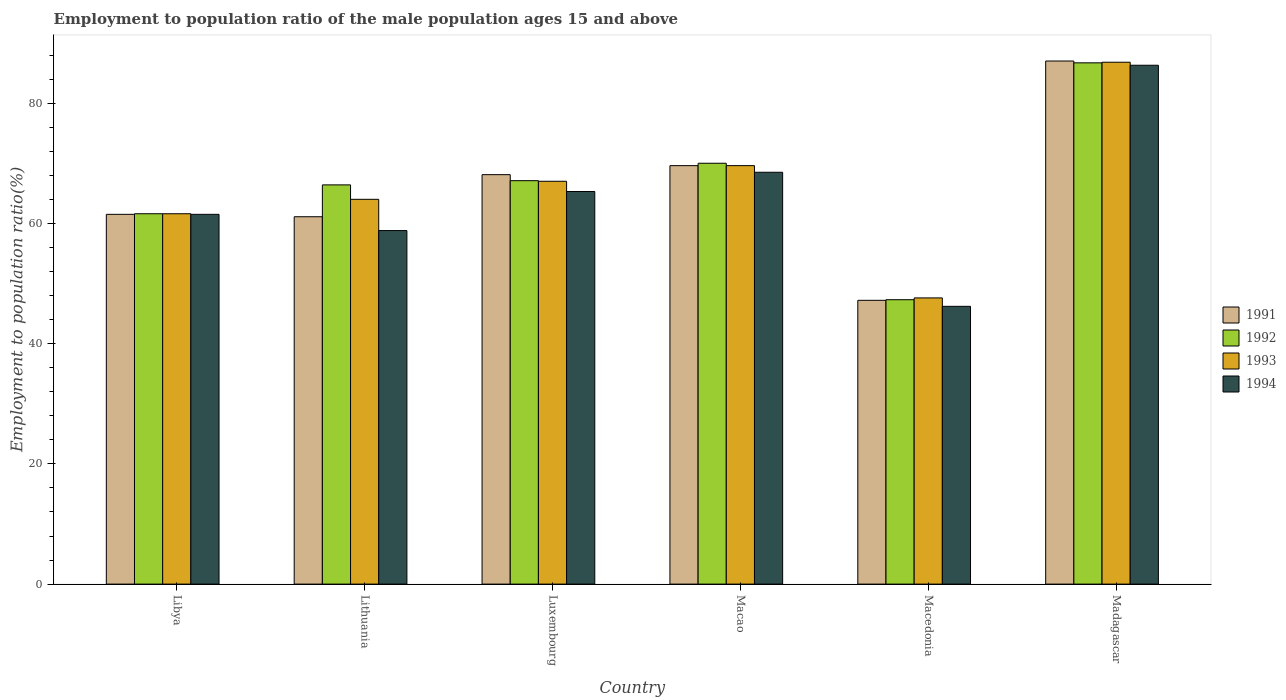Are the number of bars on each tick of the X-axis equal?
Provide a short and direct response. Yes. What is the label of the 4th group of bars from the left?
Offer a terse response. Macao. In how many cases, is the number of bars for a given country not equal to the number of legend labels?
Make the answer very short. 0. What is the employment to population ratio in 1993 in Macao?
Provide a succinct answer. 69.6. Across all countries, what is the maximum employment to population ratio in 1993?
Give a very brief answer. 86.8. Across all countries, what is the minimum employment to population ratio in 1991?
Make the answer very short. 47.2. In which country was the employment to population ratio in 1991 maximum?
Your answer should be compact. Madagascar. In which country was the employment to population ratio in 1991 minimum?
Ensure brevity in your answer.  Macedonia. What is the total employment to population ratio in 1993 in the graph?
Give a very brief answer. 396.6. What is the difference between the employment to population ratio in 1992 in Luxembourg and that in Macedonia?
Your answer should be very brief. 19.8. What is the difference between the employment to population ratio in 1992 in Macedonia and the employment to population ratio in 1993 in Luxembourg?
Keep it short and to the point. -19.7. What is the average employment to population ratio in 1993 per country?
Make the answer very short. 66.1. What is the difference between the employment to population ratio of/in 1992 and employment to population ratio of/in 1993 in Macao?
Make the answer very short. 0.4. What is the ratio of the employment to population ratio in 1993 in Luxembourg to that in Macao?
Your response must be concise. 0.96. Is the employment to population ratio in 1991 in Lithuania less than that in Madagascar?
Provide a succinct answer. Yes. Is the difference between the employment to population ratio in 1992 in Macao and Madagascar greater than the difference between the employment to population ratio in 1993 in Macao and Madagascar?
Give a very brief answer. Yes. What is the difference between the highest and the second highest employment to population ratio in 1992?
Offer a terse response. 2.9. What is the difference between the highest and the lowest employment to population ratio in 1992?
Make the answer very short. 39.4. Is the sum of the employment to population ratio in 1994 in Libya and Luxembourg greater than the maximum employment to population ratio in 1991 across all countries?
Make the answer very short. Yes. What does the 3rd bar from the right in Libya represents?
Give a very brief answer. 1992. Is it the case that in every country, the sum of the employment to population ratio in 1993 and employment to population ratio in 1994 is greater than the employment to population ratio in 1991?
Offer a terse response. Yes. How many bars are there?
Your answer should be compact. 24. Are all the bars in the graph horizontal?
Give a very brief answer. No. How many countries are there in the graph?
Provide a succinct answer. 6. What is the difference between two consecutive major ticks on the Y-axis?
Your response must be concise. 20. Are the values on the major ticks of Y-axis written in scientific E-notation?
Provide a succinct answer. No. How many legend labels are there?
Your answer should be very brief. 4. How are the legend labels stacked?
Provide a short and direct response. Vertical. What is the title of the graph?
Provide a succinct answer. Employment to population ratio of the male population ages 15 and above. Does "1977" appear as one of the legend labels in the graph?
Your answer should be compact. No. What is the label or title of the X-axis?
Ensure brevity in your answer.  Country. What is the Employment to population ratio(%) in 1991 in Libya?
Give a very brief answer. 61.5. What is the Employment to population ratio(%) in 1992 in Libya?
Your response must be concise. 61.6. What is the Employment to population ratio(%) of 1993 in Libya?
Make the answer very short. 61.6. What is the Employment to population ratio(%) in 1994 in Libya?
Offer a very short reply. 61.5. What is the Employment to population ratio(%) in 1991 in Lithuania?
Ensure brevity in your answer.  61.1. What is the Employment to population ratio(%) in 1992 in Lithuania?
Provide a succinct answer. 66.4. What is the Employment to population ratio(%) in 1993 in Lithuania?
Offer a very short reply. 64. What is the Employment to population ratio(%) in 1994 in Lithuania?
Offer a very short reply. 58.8. What is the Employment to population ratio(%) in 1991 in Luxembourg?
Offer a very short reply. 68.1. What is the Employment to population ratio(%) in 1992 in Luxembourg?
Give a very brief answer. 67.1. What is the Employment to population ratio(%) in 1993 in Luxembourg?
Give a very brief answer. 67. What is the Employment to population ratio(%) in 1994 in Luxembourg?
Ensure brevity in your answer.  65.3. What is the Employment to population ratio(%) in 1991 in Macao?
Ensure brevity in your answer.  69.6. What is the Employment to population ratio(%) of 1993 in Macao?
Give a very brief answer. 69.6. What is the Employment to population ratio(%) in 1994 in Macao?
Your answer should be very brief. 68.5. What is the Employment to population ratio(%) of 1991 in Macedonia?
Your answer should be very brief. 47.2. What is the Employment to population ratio(%) of 1992 in Macedonia?
Your response must be concise. 47.3. What is the Employment to population ratio(%) in 1993 in Macedonia?
Your response must be concise. 47.6. What is the Employment to population ratio(%) of 1994 in Macedonia?
Keep it short and to the point. 46.2. What is the Employment to population ratio(%) in 1991 in Madagascar?
Keep it short and to the point. 87. What is the Employment to population ratio(%) of 1992 in Madagascar?
Ensure brevity in your answer.  86.7. What is the Employment to population ratio(%) of 1993 in Madagascar?
Keep it short and to the point. 86.8. What is the Employment to population ratio(%) in 1994 in Madagascar?
Your answer should be compact. 86.3. Across all countries, what is the maximum Employment to population ratio(%) of 1991?
Provide a short and direct response. 87. Across all countries, what is the maximum Employment to population ratio(%) of 1992?
Offer a terse response. 86.7. Across all countries, what is the maximum Employment to population ratio(%) of 1993?
Give a very brief answer. 86.8. Across all countries, what is the maximum Employment to population ratio(%) in 1994?
Provide a succinct answer. 86.3. Across all countries, what is the minimum Employment to population ratio(%) of 1991?
Give a very brief answer. 47.2. Across all countries, what is the minimum Employment to population ratio(%) in 1992?
Offer a very short reply. 47.3. Across all countries, what is the minimum Employment to population ratio(%) in 1993?
Offer a terse response. 47.6. Across all countries, what is the minimum Employment to population ratio(%) of 1994?
Your response must be concise. 46.2. What is the total Employment to population ratio(%) of 1991 in the graph?
Keep it short and to the point. 394.5. What is the total Employment to population ratio(%) of 1992 in the graph?
Provide a succinct answer. 399.1. What is the total Employment to population ratio(%) of 1993 in the graph?
Your answer should be very brief. 396.6. What is the total Employment to population ratio(%) in 1994 in the graph?
Give a very brief answer. 386.6. What is the difference between the Employment to population ratio(%) of 1992 in Libya and that in Lithuania?
Keep it short and to the point. -4.8. What is the difference between the Employment to population ratio(%) of 1993 in Libya and that in Luxembourg?
Your answer should be very brief. -5.4. What is the difference between the Employment to population ratio(%) of 1994 in Libya and that in Luxembourg?
Keep it short and to the point. -3.8. What is the difference between the Employment to population ratio(%) of 1991 in Libya and that in Macao?
Ensure brevity in your answer.  -8.1. What is the difference between the Employment to population ratio(%) in 1992 in Libya and that in Macao?
Your answer should be very brief. -8.4. What is the difference between the Employment to population ratio(%) in 1993 in Libya and that in Macao?
Provide a short and direct response. -8. What is the difference between the Employment to population ratio(%) of 1991 in Libya and that in Macedonia?
Offer a terse response. 14.3. What is the difference between the Employment to population ratio(%) of 1994 in Libya and that in Macedonia?
Provide a short and direct response. 15.3. What is the difference between the Employment to population ratio(%) in 1991 in Libya and that in Madagascar?
Give a very brief answer. -25.5. What is the difference between the Employment to population ratio(%) in 1992 in Libya and that in Madagascar?
Your answer should be compact. -25.1. What is the difference between the Employment to population ratio(%) in 1993 in Libya and that in Madagascar?
Keep it short and to the point. -25.2. What is the difference between the Employment to population ratio(%) in 1994 in Libya and that in Madagascar?
Give a very brief answer. -24.8. What is the difference between the Employment to population ratio(%) in 1991 in Lithuania and that in Luxembourg?
Provide a succinct answer. -7. What is the difference between the Employment to population ratio(%) in 1992 in Lithuania and that in Luxembourg?
Ensure brevity in your answer.  -0.7. What is the difference between the Employment to population ratio(%) of 1993 in Lithuania and that in Luxembourg?
Give a very brief answer. -3. What is the difference between the Employment to population ratio(%) in 1994 in Lithuania and that in Luxembourg?
Offer a very short reply. -6.5. What is the difference between the Employment to population ratio(%) of 1991 in Lithuania and that in Macao?
Provide a succinct answer. -8.5. What is the difference between the Employment to population ratio(%) of 1993 in Lithuania and that in Macao?
Give a very brief answer. -5.6. What is the difference between the Employment to population ratio(%) of 1993 in Lithuania and that in Macedonia?
Offer a very short reply. 16.4. What is the difference between the Employment to population ratio(%) in 1991 in Lithuania and that in Madagascar?
Provide a succinct answer. -25.9. What is the difference between the Employment to population ratio(%) of 1992 in Lithuania and that in Madagascar?
Your answer should be very brief. -20.3. What is the difference between the Employment to population ratio(%) of 1993 in Lithuania and that in Madagascar?
Offer a terse response. -22.8. What is the difference between the Employment to population ratio(%) of 1994 in Lithuania and that in Madagascar?
Provide a short and direct response. -27.5. What is the difference between the Employment to population ratio(%) of 1991 in Luxembourg and that in Macao?
Offer a terse response. -1.5. What is the difference between the Employment to population ratio(%) of 1993 in Luxembourg and that in Macao?
Provide a short and direct response. -2.6. What is the difference between the Employment to population ratio(%) in 1991 in Luxembourg and that in Macedonia?
Your response must be concise. 20.9. What is the difference between the Employment to population ratio(%) in 1992 in Luxembourg and that in Macedonia?
Your response must be concise. 19.8. What is the difference between the Employment to population ratio(%) in 1993 in Luxembourg and that in Macedonia?
Provide a short and direct response. 19.4. What is the difference between the Employment to population ratio(%) of 1994 in Luxembourg and that in Macedonia?
Offer a very short reply. 19.1. What is the difference between the Employment to population ratio(%) of 1991 in Luxembourg and that in Madagascar?
Make the answer very short. -18.9. What is the difference between the Employment to population ratio(%) of 1992 in Luxembourg and that in Madagascar?
Your response must be concise. -19.6. What is the difference between the Employment to population ratio(%) in 1993 in Luxembourg and that in Madagascar?
Make the answer very short. -19.8. What is the difference between the Employment to population ratio(%) of 1994 in Luxembourg and that in Madagascar?
Give a very brief answer. -21. What is the difference between the Employment to population ratio(%) in 1991 in Macao and that in Macedonia?
Provide a succinct answer. 22.4. What is the difference between the Employment to population ratio(%) of 1992 in Macao and that in Macedonia?
Keep it short and to the point. 22.7. What is the difference between the Employment to population ratio(%) of 1993 in Macao and that in Macedonia?
Your response must be concise. 22. What is the difference between the Employment to population ratio(%) in 1994 in Macao and that in Macedonia?
Your response must be concise. 22.3. What is the difference between the Employment to population ratio(%) of 1991 in Macao and that in Madagascar?
Offer a very short reply. -17.4. What is the difference between the Employment to population ratio(%) in 1992 in Macao and that in Madagascar?
Provide a succinct answer. -16.7. What is the difference between the Employment to population ratio(%) in 1993 in Macao and that in Madagascar?
Provide a short and direct response. -17.2. What is the difference between the Employment to population ratio(%) of 1994 in Macao and that in Madagascar?
Offer a very short reply. -17.8. What is the difference between the Employment to population ratio(%) of 1991 in Macedonia and that in Madagascar?
Offer a terse response. -39.8. What is the difference between the Employment to population ratio(%) in 1992 in Macedonia and that in Madagascar?
Your answer should be very brief. -39.4. What is the difference between the Employment to population ratio(%) in 1993 in Macedonia and that in Madagascar?
Your response must be concise. -39.2. What is the difference between the Employment to population ratio(%) in 1994 in Macedonia and that in Madagascar?
Your answer should be very brief. -40.1. What is the difference between the Employment to population ratio(%) in 1991 in Libya and the Employment to population ratio(%) in 1992 in Lithuania?
Offer a very short reply. -4.9. What is the difference between the Employment to population ratio(%) of 1991 in Libya and the Employment to population ratio(%) of 1993 in Lithuania?
Give a very brief answer. -2.5. What is the difference between the Employment to population ratio(%) of 1991 in Libya and the Employment to population ratio(%) of 1994 in Lithuania?
Offer a terse response. 2.7. What is the difference between the Employment to population ratio(%) of 1992 in Libya and the Employment to population ratio(%) of 1993 in Lithuania?
Your answer should be compact. -2.4. What is the difference between the Employment to population ratio(%) in 1993 in Libya and the Employment to population ratio(%) in 1994 in Lithuania?
Offer a terse response. 2.8. What is the difference between the Employment to population ratio(%) in 1991 in Libya and the Employment to population ratio(%) in 1992 in Luxembourg?
Your answer should be compact. -5.6. What is the difference between the Employment to population ratio(%) of 1992 in Libya and the Employment to population ratio(%) of 1994 in Luxembourg?
Your answer should be very brief. -3.7. What is the difference between the Employment to population ratio(%) in 1993 in Libya and the Employment to population ratio(%) in 1994 in Luxembourg?
Ensure brevity in your answer.  -3.7. What is the difference between the Employment to population ratio(%) of 1991 in Libya and the Employment to population ratio(%) of 1993 in Macao?
Offer a terse response. -8.1. What is the difference between the Employment to population ratio(%) of 1992 in Libya and the Employment to population ratio(%) of 1994 in Macao?
Offer a very short reply. -6.9. What is the difference between the Employment to population ratio(%) of 1993 in Libya and the Employment to population ratio(%) of 1994 in Macao?
Provide a succinct answer. -6.9. What is the difference between the Employment to population ratio(%) in 1992 in Libya and the Employment to population ratio(%) in 1993 in Macedonia?
Ensure brevity in your answer.  14. What is the difference between the Employment to population ratio(%) in 1991 in Libya and the Employment to population ratio(%) in 1992 in Madagascar?
Provide a succinct answer. -25.2. What is the difference between the Employment to population ratio(%) of 1991 in Libya and the Employment to population ratio(%) of 1993 in Madagascar?
Provide a succinct answer. -25.3. What is the difference between the Employment to population ratio(%) in 1991 in Libya and the Employment to population ratio(%) in 1994 in Madagascar?
Offer a terse response. -24.8. What is the difference between the Employment to population ratio(%) of 1992 in Libya and the Employment to population ratio(%) of 1993 in Madagascar?
Ensure brevity in your answer.  -25.2. What is the difference between the Employment to population ratio(%) of 1992 in Libya and the Employment to population ratio(%) of 1994 in Madagascar?
Provide a short and direct response. -24.7. What is the difference between the Employment to population ratio(%) of 1993 in Libya and the Employment to population ratio(%) of 1994 in Madagascar?
Provide a succinct answer. -24.7. What is the difference between the Employment to population ratio(%) in 1991 in Lithuania and the Employment to population ratio(%) in 1992 in Luxembourg?
Your answer should be very brief. -6. What is the difference between the Employment to population ratio(%) in 1992 in Lithuania and the Employment to population ratio(%) in 1994 in Luxembourg?
Provide a short and direct response. 1.1. What is the difference between the Employment to population ratio(%) of 1991 in Lithuania and the Employment to population ratio(%) of 1993 in Macao?
Make the answer very short. -8.5. What is the difference between the Employment to population ratio(%) of 1991 in Lithuania and the Employment to population ratio(%) of 1994 in Macao?
Your response must be concise. -7.4. What is the difference between the Employment to population ratio(%) in 1992 in Lithuania and the Employment to population ratio(%) in 1993 in Macao?
Provide a succinct answer. -3.2. What is the difference between the Employment to population ratio(%) of 1991 in Lithuania and the Employment to population ratio(%) of 1992 in Macedonia?
Offer a very short reply. 13.8. What is the difference between the Employment to population ratio(%) of 1991 in Lithuania and the Employment to population ratio(%) of 1993 in Macedonia?
Ensure brevity in your answer.  13.5. What is the difference between the Employment to population ratio(%) of 1991 in Lithuania and the Employment to population ratio(%) of 1994 in Macedonia?
Keep it short and to the point. 14.9. What is the difference between the Employment to population ratio(%) of 1992 in Lithuania and the Employment to population ratio(%) of 1994 in Macedonia?
Offer a terse response. 20.2. What is the difference between the Employment to population ratio(%) of 1993 in Lithuania and the Employment to population ratio(%) of 1994 in Macedonia?
Keep it short and to the point. 17.8. What is the difference between the Employment to population ratio(%) in 1991 in Lithuania and the Employment to population ratio(%) in 1992 in Madagascar?
Your answer should be very brief. -25.6. What is the difference between the Employment to population ratio(%) of 1991 in Lithuania and the Employment to population ratio(%) of 1993 in Madagascar?
Your answer should be compact. -25.7. What is the difference between the Employment to population ratio(%) of 1991 in Lithuania and the Employment to population ratio(%) of 1994 in Madagascar?
Offer a terse response. -25.2. What is the difference between the Employment to population ratio(%) of 1992 in Lithuania and the Employment to population ratio(%) of 1993 in Madagascar?
Give a very brief answer. -20.4. What is the difference between the Employment to population ratio(%) of 1992 in Lithuania and the Employment to population ratio(%) of 1994 in Madagascar?
Ensure brevity in your answer.  -19.9. What is the difference between the Employment to population ratio(%) in 1993 in Lithuania and the Employment to population ratio(%) in 1994 in Madagascar?
Your answer should be compact. -22.3. What is the difference between the Employment to population ratio(%) in 1991 in Luxembourg and the Employment to population ratio(%) in 1993 in Macao?
Provide a succinct answer. -1.5. What is the difference between the Employment to population ratio(%) of 1991 in Luxembourg and the Employment to population ratio(%) of 1994 in Macao?
Ensure brevity in your answer.  -0.4. What is the difference between the Employment to population ratio(%) of 1992 in Luxembourg and the Employment to population ratio(%) of 1993 in Macao?
Ensure brevity in your answer.  -2.5. What is the difference between the Employment to population ratio(%) in 1992 in Luxembourg and the Employment to population ratio(%) in 1994 in Macao?
Offer a very short reply. -1.4. What is the difference between the Employment to population ratio(%) in 1991 in Luxembourg and the Employment to population ratio(%) in 1992 in Macedonia?
Your answer should be compact. 20.8. What is the difference between the Employment to population ratio(%) in 1991 in Luxembourg and the Employment to population ratio(%) in 1993 in Macedonia?
Provide a succinct answer. 20.5. What is the difference between the Employment to population ratio(%) of 1991 in Luxembourg and the Employment to population ratio(%) of 1994 in Macedonia?
Offer a terse response. 21.9. What is the difference between the Employment to population ratio(%) of 1992 in Luxembourg and the Employment to population ratio(%) of 1993 in Macedonia?
Your response must be concise. 19.5. What is the difference between the Employment to population ratio(%) of 1992 in Luxembourg and the Employment to population ratio(%) of 1994 in Macedonia?
Ensure brevity in your answer.  20.9. What is the difference between the Employment to population ratio(%) in 1993 in Luxembourg and the Employment to population ratio(%) in 1994 in Macedonia?
Your answer should be compact. 20.8. What is the difference between the Employment to population ratio(%) in 1991 in Luxembourg and the Employment to population ratio(%) in 1992 in Madagascar?
Provide a short and direct response. -18.6. What is the difference between the Employment to population ratio(%) in 1991 in Luxembourg and the Employment to population ratio(%) in 1993 in Madagascar?
Offer a terse response. -18.7. What is the difference between the Employment to population ratio(%) in 1991 in Luxembourg and the Employment to population ratio(%) in 1994 in Madagascar?
Make the answer very short. -18.2. What is the difference between the Employment to population ratio(%) in 1992 in Luxembourg and the Employment to population ratio(%) in 1993 in Madagascar?
Your answer should be compact. -19.7. What is the difference between the Employment to population ratio(%) in 1992 in Luxembourg and the Employment to population ratio(%) in 1994 in Madagascar?
Ensure brevity in your answer.  -19.2. What is the difference between the Employment to population ratio(%) of 1993 in Luxembourg and the Employment to population ratio(%) of 1994 in Madagascar?
Offer a terse response. -19.3. What is the difference between the Employment to population ratio(%) of 1991 in Macao and the Employment to population ratio(%) of 1992 in Macedonia?
Keep it short and to the point. 22.3. What is the difference between the Employment to population ratio(%) of 1991 in Macao and the Employment to population ratio(%) of 1993 in Macedonia?
Give a very brief answer. 22. What is the difference between the Employment to population ratio(%) of 1991 in Macao and the Employment to population ratio(%) of 1994 in Macedonia?
Give a very brief answer. 23.4. What is the difference between the Employment to population ratio(%) of 1992 in Macao and the Employment to population ratio(%) of 1993 in Macedonia?
Provide a short and direct response. 22.4. What is the difference between the Employment to population ratio(%) of 1992 in Macao and the Employment to population ratio(%) of 1994 in Macedonia?
Provide a succinct answer. 23.8. What is the difference between the Employment to population ratio(%) in 1993 in Macao and the Employment to population ratio(%) in 1994 in Macedonia?
Offer a terse response. 23.4. What is the difference between the Employment to population ratio(%) of 1991 in Macao and the Employment to population ratio(%) of 1992 in Madagascar?
Make the answer very short. -17.1. What is the difference between the Employment to population ratio(%) of 1991 in Macao and the Employment to population ratio(%) of 1993 in Madagascar?
Your answer should be very brief. -17.2. What is the difference between the Employment to population ratio(%) of 1991 in Macao and the Employment to population ratio(%) of 1994 in Madagascar?
Offer a very short reply. -16.7. What is the difference between the Employment to population ratio(%) in 1992 in Macao and the Employment to population ratio(%) in 1993 in Madagascar?
Ensure brevity in your answer.  -16.8. What is the difference between the Employment to population ratio(%) of 1992 in Macao and the Employment to population ratio(%) of 1994 in Madagascar?
Your answer should be compact. -16.3. What is the difference between the Employment to population ratio(%) in 1993 in Macao and the Employment to population ratio(%) in 1994 in Madagascar?
Make the answer very short. -16.7. What is the difference between the Employment to population ratio(%) of 1991 in Macedonia and the Employment to population ratio(%) of 1992 in Madagascar?
Offer a terse response. -39.5. What is the difference between the Employment to population ratio(%) of 1991 in Macedonia and the Employment to population ratio(%) of 1993 in Madagascar?
Your response must be concise. -39.6. What is the difference between the Employment to population ratio(%) in 1991 in Macedonia and the Employment to population ratio(%) in 1994 in Madagascar?
Offer a very short reply. -39.1. What is the difference between the Employment to population ratio(%) in 1992 in Macedonia and the Employment to population ratio(%) in 1993 in Madagascar?
Your answer should be very brief. -39.5. What is the difference between the Employment to population ratio(%) of 1992 in Macedonia and the Employment to population ratio(%) of 1994 in Madagascar?
Keep it short and to the point. -39. What is the difference between the Employment to population ratio(%) of 1993 in Macedonia and the Employment to population ratio(%) of 1994 in Madagascar?
Your answer should be very brief. -38.7. What is the average Employment to population ratio(%) of 1991 per country?
Keep it short and to the point. 65.75. What is the average Employment to population ratio(%) in 1992 per country?
Provide a succinct answer. 66.52. What is the average Employment to population ratio(%) in 1993 per country?
Offer a very short reply. 66.1. What is the average Employment to population ratio(%) in 1994 per country?
Your answer should be very brief. 64.43. What is the difference between the Employment to population ratio(%) of 1991 and Employment to population ratio(%) of 1993 in Libya?
Make the answer very short. -0.1. What is the difference between the Employment to population ratio(%) in 1992 and Employment to population ratio(%) in 1993 in Libya?
Offer a very short reply. 0. What is the difference between the Employment to population ratio(%) of 1992 and Employment to population ratio(%) of 1994 in Libya?
Your answer should be compact. 0.1. What is the difference between the Employment to population ratio(%) of 1993 and Employment to population ratio(%) of 1994 in Libya?
Provide a short and direct response. 0.1. What is the difference between the Employment to population ratio(%) in 1991 and Employment to population ratio(%) in 1993 in Lithuania?
Keep it short and to the point. -2.9. What is the difference between the Employment to population ratio(%) in 1992 and Employment to population ratio(%) in 1993 in Lithuania?
Keep it short and to the point. 2.4. What is the difference between the Employment to population ratio(%) in 1991 and Employment to population ratio(%) in 1992 in Luxembourg?
Your answer should be compact. 1. What is the difference between the Employment to population ratio(%) of 1992 and Employment to population ratio(%) of 1994 in Luxembourg?
Your answer should be very brief. 1.8. What is the difference between the Employment to population ratio(%) of 1993 and Employment to population ratio(%) of 1994 in Luxembourg?
Offer a very short reply. 1.7. What is the difference between the Employment to population ratio(%) in 1991 and Employment to population ratio(%) in 1993 in Macao?
Provide a short and direct response. 0. What is the difference between the Employment to population ratio(%) in 1992 and Employment to population ratio(%) in 1993 in Macao?
Your response must be concise. 0.4. What is the difference between the Employment to population ratio(%) of 1992 and Employment to population ratio(%) of 1994 in Macao?
Your response must be concise. 1.5. What is the difference between the Employment to population ratio(%) in 1991 and Employment to population ratio(%) in 1993 in Macedonia?
Provide a succinct answer. -0.4. What is the difference between the Employment to population ratio(%) in 1991 and Employment to population ratio(%) in 1994 in Macedonia?
Provide a succinct answer. 1. What is the difference between the Employment to population ratio(%) in 1992 and Employment to population ratio(%) in 1993 in Macedonia?
Your response must be concise. -0.3. What is the difference between the Employment to population ratio(%) in 1991 and Employment to population ratio(%) in 1992 in Madagascar?
Your response must be concise. 0.3. What is the difference between the Employment to population ratio(%) in 1991 and Employment to population ratio(%) in 1994 in Madagascar?
Your answer should be very brief. 0.7. What is the ratio of the Employment to population ratio(%) in 1992 in Libya to that in Lithuania?
Your answer should be very brief. 0.93. What is the ratio of the Employment to population ratio(%) of 1993 in Libya to that in Lithuania?
Offer a terse response. 0.96. What is the ratio of the Employment to population ratio(%) in 1994 in Libya to that in Lithuania?
Make the answer very short. 1.05. What is the ratio of the Employment to population ratio(%) of 1991 in Libya to that in Luxembourg?
Offer a terse response. 0.9. What is the ratio of the Employment to population ratio(%) in 1992 in Libya to that in Luxembourg?
Your answer should be compact. 0.92. What is the ratio of the Employment to population ratio(%) in 1993 in Libya to that in Luxembourg?
Provide a succinct answer. 0.92. What is the ratio of the Employment to population ratio(%) in 1994 in Libya to that in Luxembourg?
Ensure brevity in your answer.  0.94. What is the ratio of the Employment to population ratio(%) of 1991 in Libya to that in Macao?
Offer a terse response. 0.88. What is the ratio of the Employment to population ratio(%) in 1993 in Libya to that in Macao?
Make the answer very short. 0.89. What is the ratio of the Employment to population ratio(%) of 1994 in Libya to that in Macao?
Your answer should be compact. 0.9. What is the ratio of the Employment to population ratio(%) of 1991 in Libya to that in Macedonia?
Your response must be concise. 1.3. What is the ratio of the Employment to population ratio(%) in 1992 in Libya to that in Macedonia?
Provide a short and direct response. 1.3. What is the ratio of the Employment to population ratio(%) of 1993 in Libya to that in Macedonia?
Offer a terse response. 1.29. What is the ratio of the Employment to population ratio(%) of 1994 in Libya to that in Macedonia?
Keep it short and to the point. 1.33. What is the ratio of the Employment to population ratio(%) in 1991 in Libya to that in Madagascar?
Your response must be concise. 0.71. What is the ratio of the Employment to population ratio(%) in 1992 in Libya to that in Madagascar?
Offer a very short reply. 0.71. What is the ratio of the Employment to population ratio(%) in 1993 in Libya to that in Madagascar?
Offer a very short reply. 0.71. What is the ratio of the Employment to population ratio(%) of 1994 in Libya to that in Madagascar?
Keep it short and to the point. 0.71. What is the ratio of the Employment to population ratio(%) of 1991 in Lithuania to that in Luxembourg?
Offer a terse response. 0.9. What is the ratio of the Employment to population ratio(%) in 1992 in Lithuania to that in Luxembourg?
Keep it short and to the point. 0.99. What is the ratio of the Employment to population ratio(%) of 1993 in Lithuania to that in Luxembourg?
Offer a terse response. 0.96. What is the ratio of the Employment to population ratio(%) in 1994 in Lithuania to that in Luxembourg?
Provide a short and direct response. 0.9. What is the ratio of the Employment to population ratio(%) of 1991 in Lithuania to that in Macao?
Give a very brief answer. 0.88. What is the ratio of the Employment to population ratio(%) in 1992 in Lithuania to that in Macao?
Provide a succinct answer. 0.95. What is the ratio of the Employment to population ratio(%) in 1993 in Lithuania to that in Macao?
Your answer should be very brief. 0.92. What is the ratio of the Employment to population ratio(%) of 1994 in Lithuania to that in Macao?
Offer a terse response. 0.86. What is the ratio of the Employment to population ratio(%) of 1991 in Lithuania to that in Macedonia?
Ensure brevity in your answer.  1.29. What is the ratio of the Employment to population ratio(%) of 1992 in Lithuania to that in Macedonia?
Your response must be concise. 1.4. What is the ratio of the Employment to population ratio(%) of 1993 in Lithuania to that in Macedonia?
Offer a very short reply. 1.34. What is the ratio of the Employment to population ratio(%) in 1994 in Lithuania to that in Macedonia?
Your answer should be compact. 1.27. What is the ratio of the Employment to population ratio(%) of 1991 in Lithuania to that in Madagascar?
Provide a short and direct response. 0.7. What is the ratio of the Employment to population ratio(%) of 1992 in Lithuania to that in Madagascar?
Keep it short and to the point. 0.77. What is the ratio of the Employment to population ratio(%) of 1993 in Lithuania to that in Madagascar?
Ensure brevity in your answer.  0.74. What is the ratio of the Employment to population ratio(%) in 1994 in Lithuania to that in Madagascar?
Your answer should be very brief. 0.68. What is the ratio of the Employment to population ratio(%) of 1991 in Luxembourg to that in Macao?
Keep it short and to the point. 0.98. What is the ratio of the Employment to population ratio(%) of 1992 in Luxembourg to that in Macao?
Give a very brief answer. 0.96. What is the ratio of the Employment to population ratio(%) in 1993 in Luxembourg to that in Macao?
Your answer should be compact. 0.96. What is the ratio of the Employment to population ratio(%) in 1994 in Luxembourg to that in Macao?
Provide a short and direct response. 0.95. What is the ratio of the Employment to population ratio(%) in 1991 in Luxembourg to that in Macedonia?
Offer a very short reply. 1.44. What is the ratio of the Employment to population ratio(%) of 1992 in Luxembourg to that in Macedonia?
Your answer should be very brief. 1.42. What is the ratio of the Employment to population ratio(%) of 1993 in Luxembourg to that in Macedonia?
Offer a very short reply. 1.41. What is the ratio of the Employment to population ratio(%) in 1994 in Luxembourg to that in Macedonia?
Your answer should be very brief. 1.41. What is the ratio of the Employment to population ratio(%) of 1991 in Luxembourg to that in Madagascar?
Offer a very short reply. 0.78. What is the ratio of the Employment to population ratio(%) in 1992 in Luxembourg to that in Madagascar?
Offer a very short reply. 0.77. What is the ratio of the Employment to population ratio(%) in 1993 in Luxembourg to that in Madagascar?
Your answer should be very brief. 0.77. What is the ratio of the Employment to population ratio(%) of 1994 in Luxembourg to that in Madagascar?
Your answer should be compact. 0.76. What is the ratio of the Employment to population ratio(%) in 1991 in Macao to that in Macedonia?
Ensure brevity in your answer.  1.47. What is the ratio of the Employment to population ratio(%) in 1992 in Macao to that in Macedonia?
Your answer should be compact. 1.48. What is the ratio of the Employment to population ratio(%) of 1993 in Macao to that in Macedonia?
Ensure brevity in your answer.  1.46. What is the ratio of the Employment to population ratio(%) in 1994 in Macao to that in Macedonia?
Provide a short and direct response. 1.48. What is the ratio of the Employment to population ratio(%) in 1992 in Macao to that in Madagascar?
Offer a very short reply. 0.81. What is the ratio of the Employment to population ratio(%) in 1993 in Macao to that in Madagascar?
Make the answer very short. 0.8. What is the ratio of the Employment to population ratio(%) in 1994 in Macao to that in Madagascar?
Keep it short and to the point. 0.79. What is the ratio of the Employment to population ratio(%) of 1991 in Macedonia to that in Madagascar?
Provide a short and direct response. 0.54. What is the ratio of the Employment to population ratio(%) of 1992 in Macedonia to that in Madagascar?
Give a very brief answer. 0.55. What is the ratio of the Employment to population ratio(%) of 1993 in Macedonia to that in Madagascar?
Ensure brevity in your answer.  0.55. What is the ratio of the Employment to population ratio(%) in 1994 in Macedonia to that in Madagascar?
Your answer should be compact. 0.54. What is the difference between the highest and the second highest Employment to population ratio(%) of 1993?
Your answer should be very brief. 17.2. What is the difference between the highest and the second highest Employment to population ratio(%) in 1994?
Make the answer very short. 17.8. What is the difference between the highest and the lowest Employment to population ratio(%) in 1991?
Give a very brief answer. 39.8. What is the difference between the highest and the lowest Employment to population ratio(%) in 1992?
Provide a succinct answer. 39.4. What is the difference between the highest and the lowest Employment to population ratio(%) of 1993?
Offer a terse response. 39.2. What is the difference between the highest and the lowest Employment to population ratio(%) in 1994?
Ensure brevity in your answer.  40.1. 